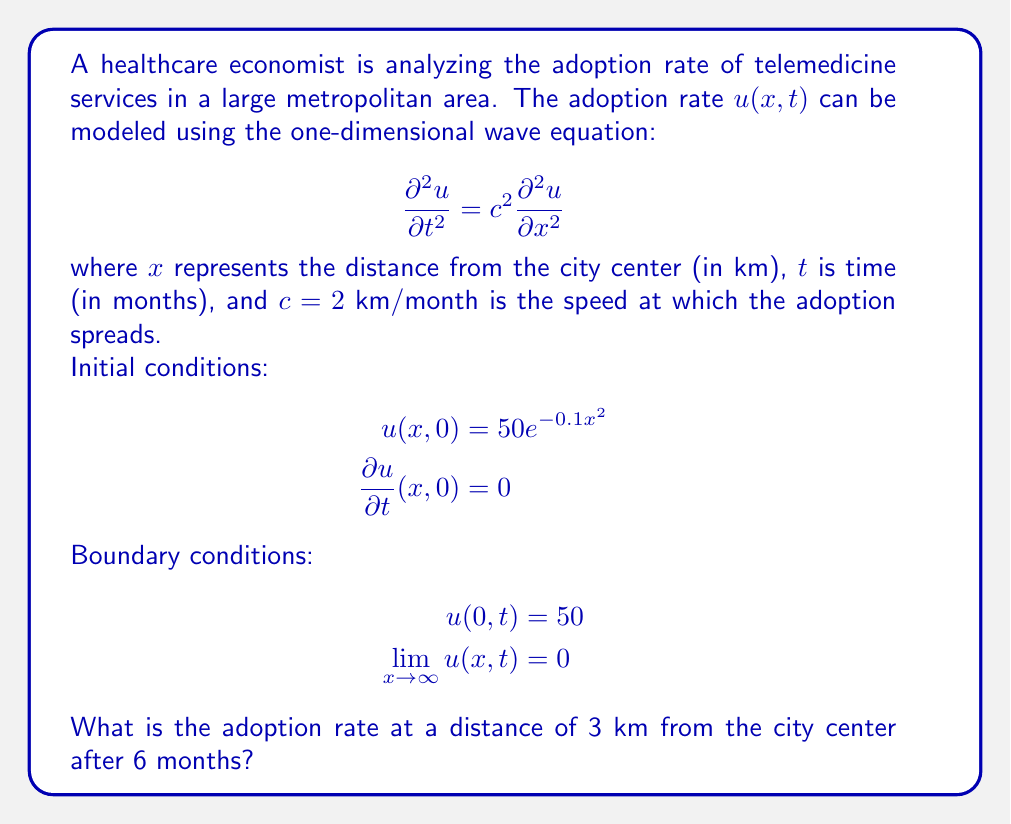Can you solve this math problem? To solve this problem, we need to use D'Alembert's solution for the one-dimensional wave equation. The general solution is:

$$u(x,t) = \frac{1}{2}[f(x+ct) + f(x-ct)] + \frac{1}{2c}\int_{x-ct}^{x+ct} g(s) ds$$

where $f(x)$ is the initial displacement and $g(x)$ is the initial velocity.

Given:
1. $c = 2$ km/month
2. $f(x) = u(x,0) = 50e^{-0.1x^2}$
3. $g(x) = \frac{\partial u}{\partial t}(x,0) = 0$

Step 1: Simplify the solution due to zero initial velocity.
$$u(x,t) = \frac{1}{2}[f(x+ct) + f(x-ct)]$$

Step 2: Substitute the given functions.
$$u(x,t) = \frac{1}{2}[50e^{-0.1(x+ct)^2} + 50e^{-0.1(x-ct)^2}]$$

Step 3: Calculate for $x = 3$ km and $t = 6$ months.
$$u(3,6) = \frac{1}{2}[50e^{-0.1(3+2*6)^2} + 50e^{-0.1(3-2*6)^2}]$$
$$u(3,6) = \frac{1}{2}[50e^{-0.1(15)^2} + 50e^{-0.1(-9)^2}]$$

Step 4: Evaluate the exponentials.
$$u(3,6) = \frac{1}{2}[50e^{-22.5} + 50e^{-8.1}]$$
$$u(3,6) = \frac{1}{2}[50(1.69 \times 10^{-10}) + 50(0.0003052)]$$

Step 5: Calculate the final result.
$$u(3,6) = \frac{1}{2}[8.45 \times 10^{-9} + 0.01526]$$
$$u(3,6) \approx 0.007630$$
Answer: 0.007630 